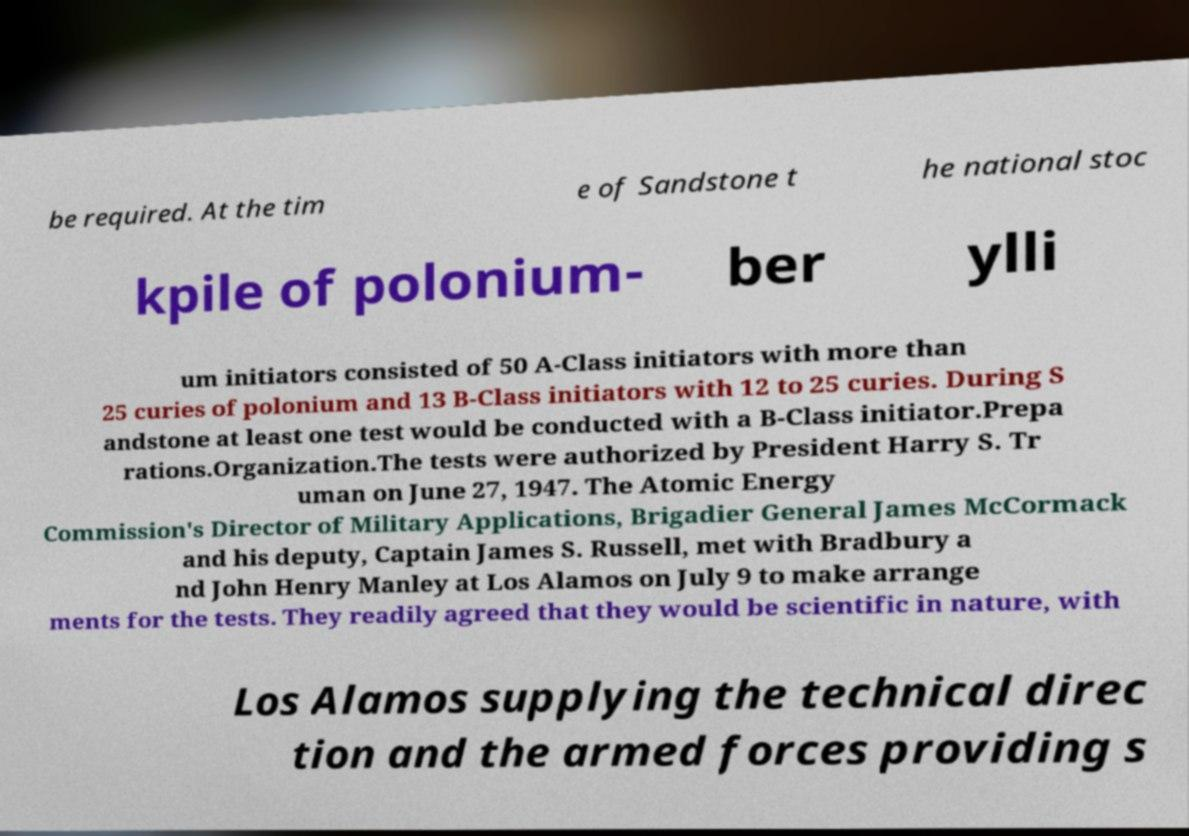What messages or text are displayed in this image? I need them in a readable, typed format. be required. At the tim e of Sandstone t he national stoc kpile of polonium- ber ylli um initiators consisted of 50 A-Class initiators with more than 25 curies of polonium and 13 B-Class initiators with 12 to 25 curies. During S andstone at least one test would be conducted with a B-Class initiator.Prepa rations.Organization.The tests were authorized by President Harry S. Tr uman on June 27, 1947. The Atomic Energy Commission's Director of Military Applications, Brigadier General James McCormack and his deputy, Captain James S. Russell, met with Bradbury a nd John Henry Manley at Los Alamos on July 9 to make arrange ments for the tests. They readily agreed that they would be scientific in nature, with Los Alamos supplying the technical direc tion and the armed forces providing s 